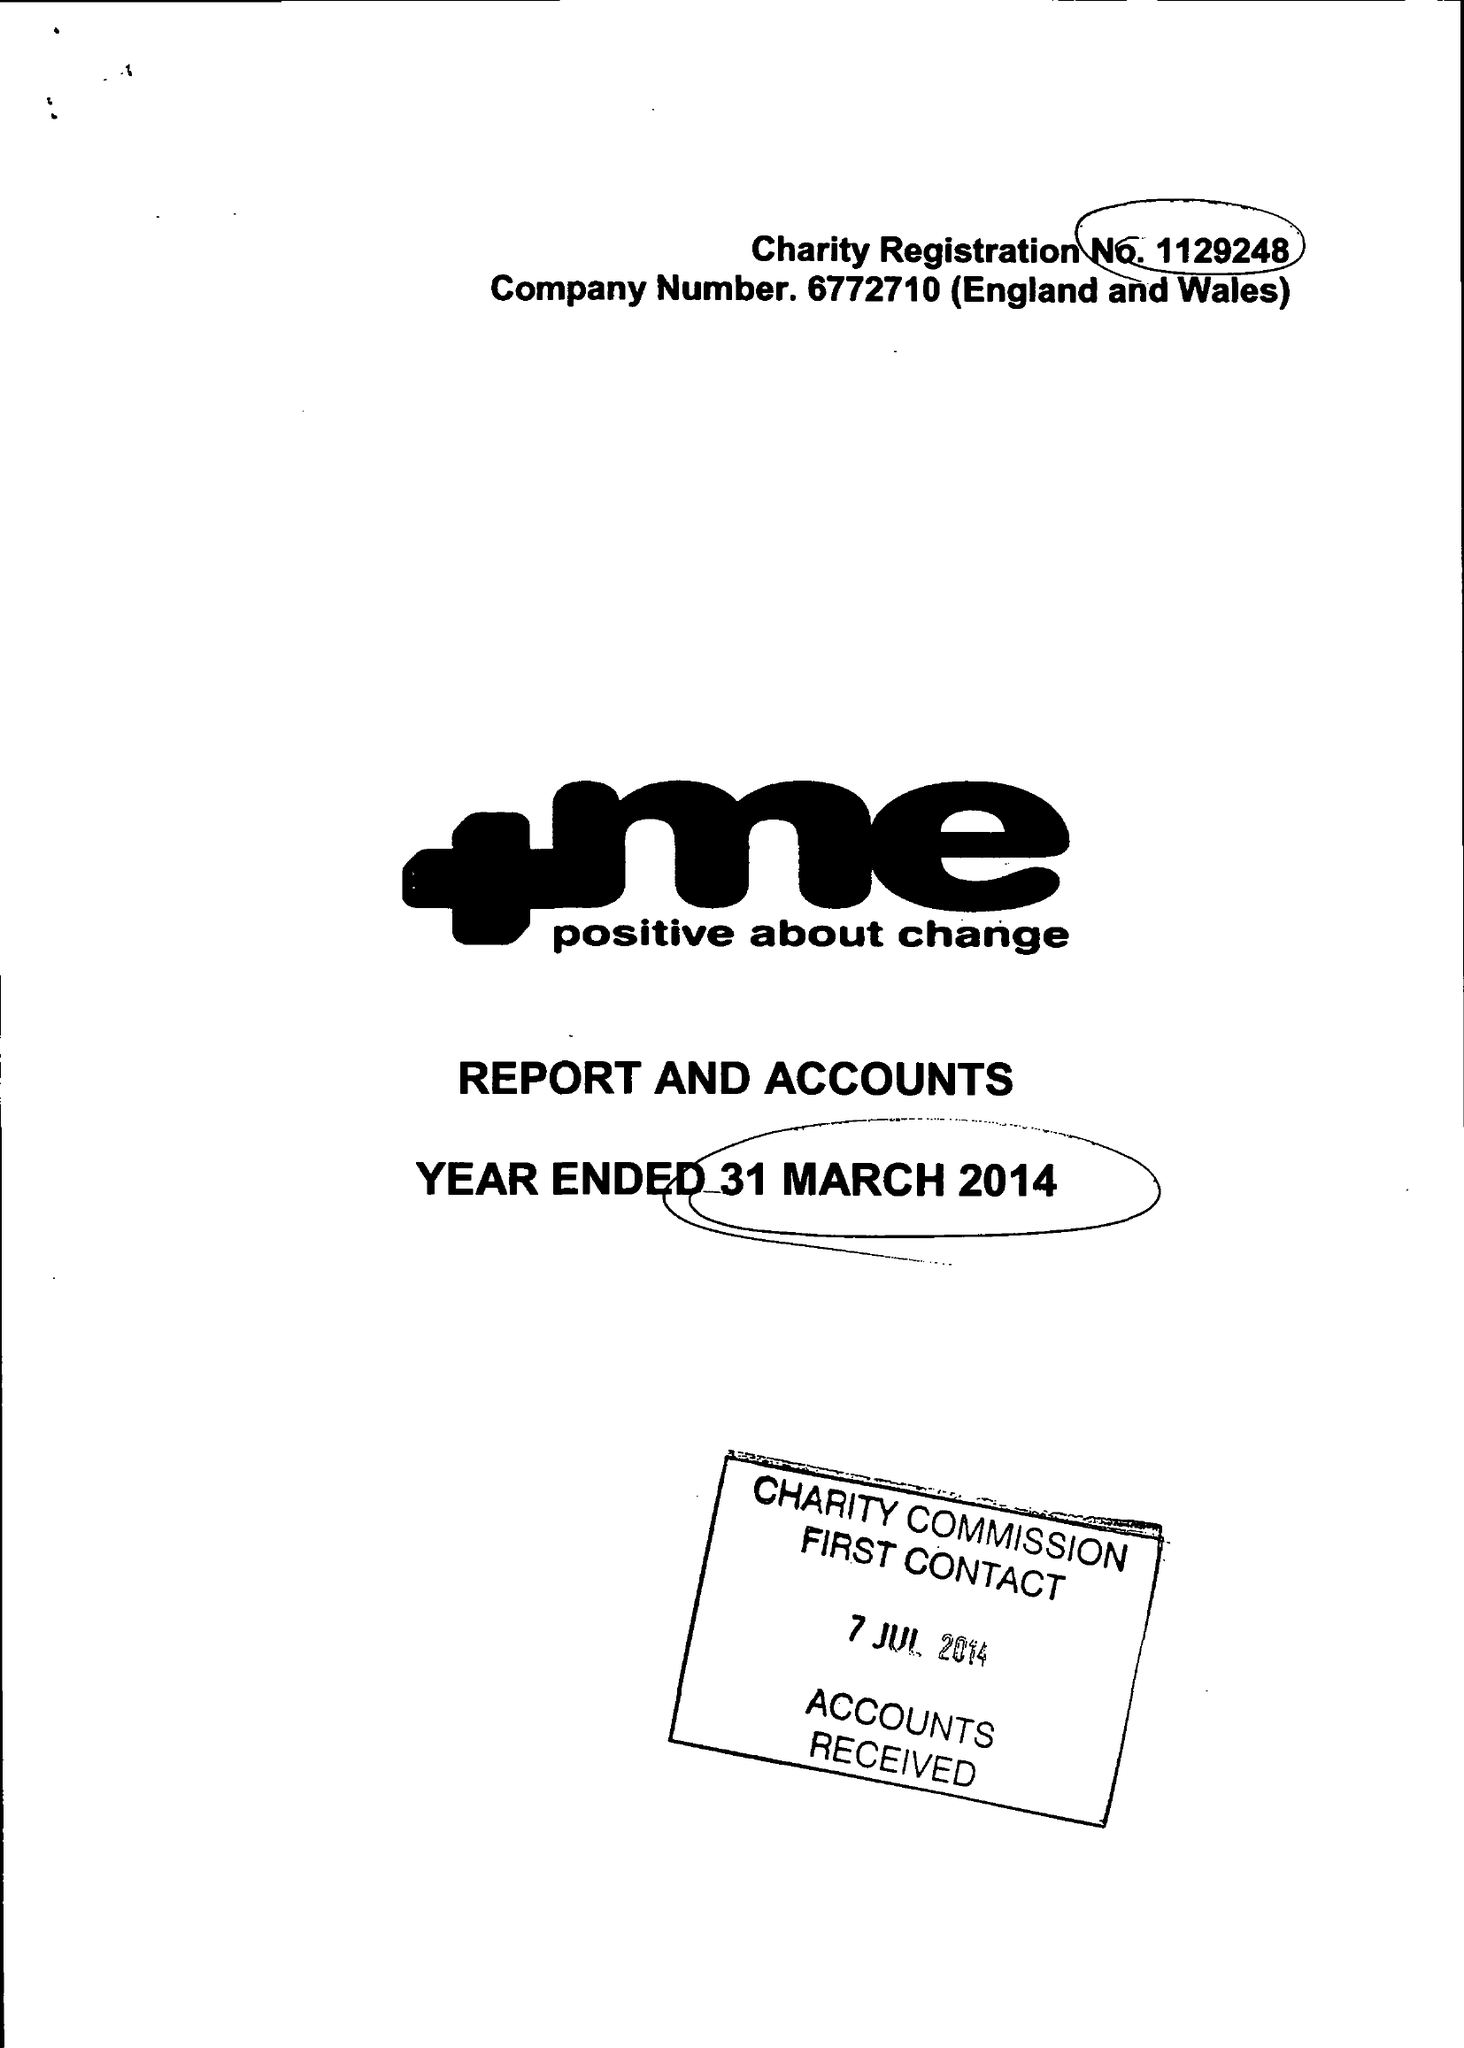What is the value for the address__post_town?
Answer the question using a single word or phrase. BARNSLEY 